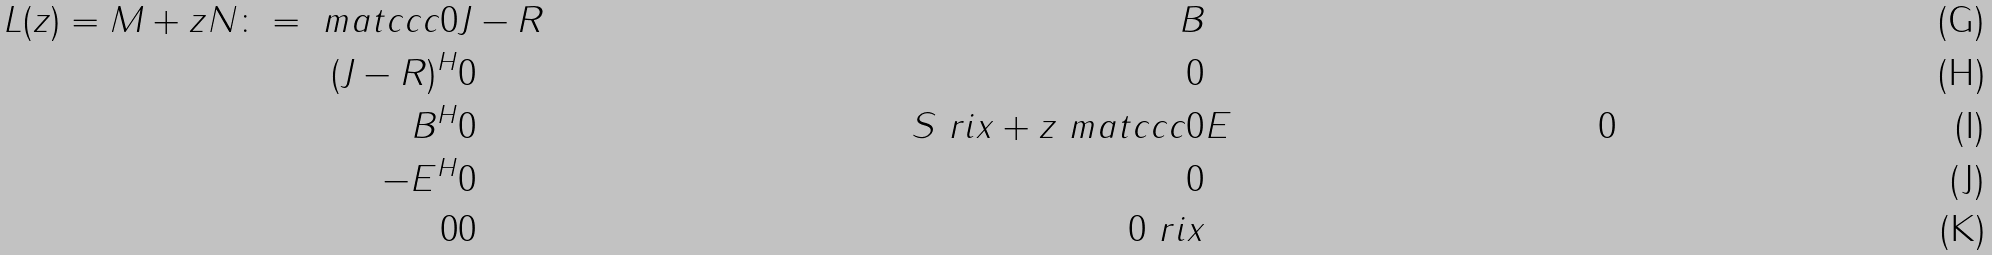Convert formula to latex. <formula><loc_0><loc_0><loc_500><loc_500>L ( z ) = M + z N \colon = \ m a t { c c c } 0 & J - R & B \\ ( J - R ) ^ { H } & 0 & 0 \\ B ^ { H } & 0 & S \ r i x + z \ m a t { c c c } 0 & E & 0 \\ - E ^ { H } & 0 & 0 \\ 0 & 0 & 0 \ r i x</formula> 